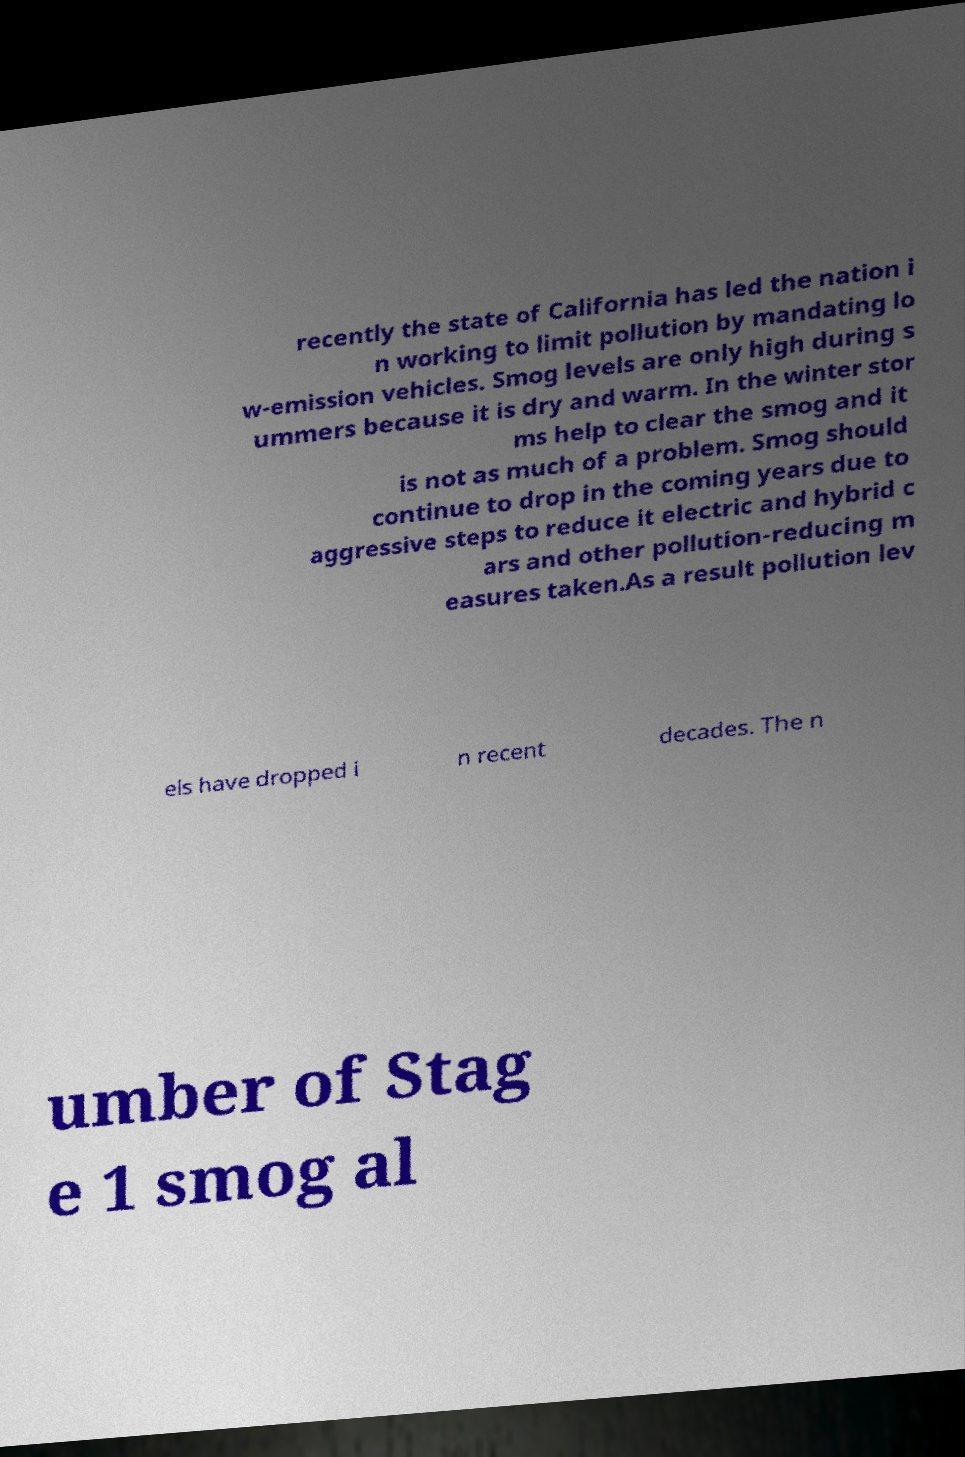Could you extract and type out the text from this image? recently the state of California has led the nation i n working to limit pollution by mandating lo w-emission vehicles. Smog levels are only high during s ummers because it is dry and warm. In the winter stor ms help to clear the smog and it is not as much of a problem. Smog should continue to drop in the coming years due to aggressive steps to reduce it electric and hybrid c ars and other pollution-reducing m easures taken.As a result pollution lev els have dropped i n recent decades. The n umber of Stag e 1 smog al 